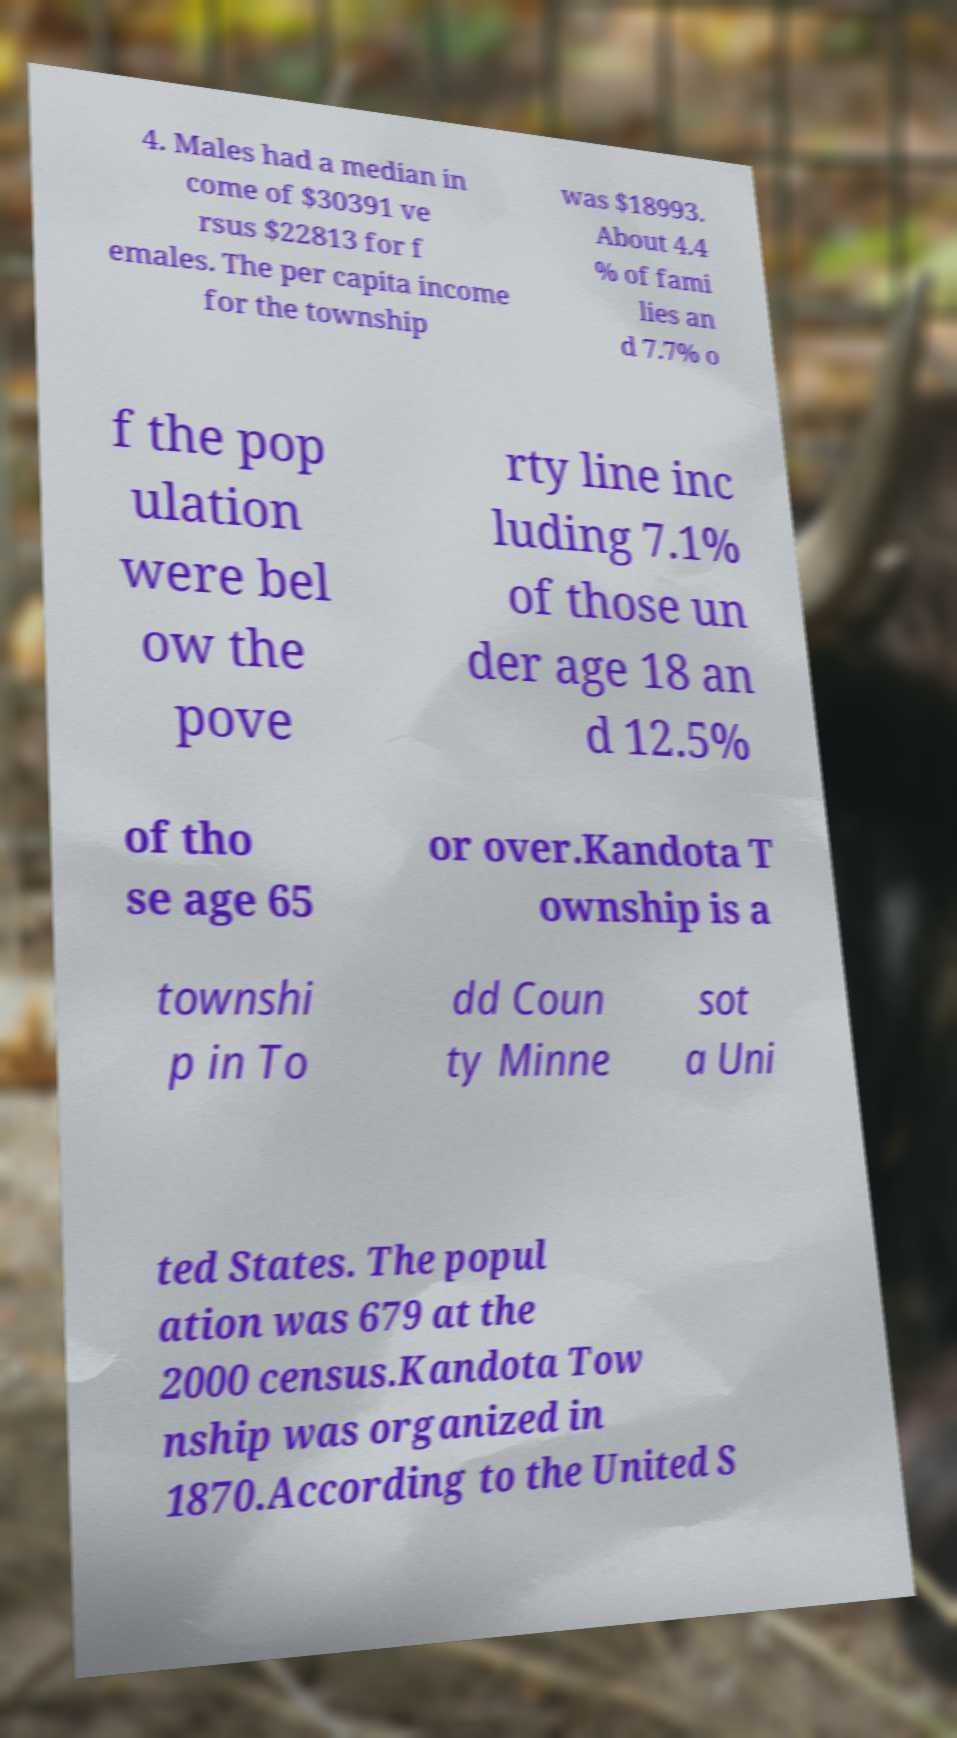Can you accurately transcribe the text from the provided image for me? 4. Males had a median in come of $30391 ve rsus $22813 for f emales. The per capita income for the township was $18993. About 4.4 % of fami lies an d 7.7% o f the pop ulation were bel ow the pove rty line inc luding 7.1% of those un der age 18 an d 12.5% of tho se age 65 or over.Kandota T ownship is a townshi p in To dd Coun ty Minne sot a Uni ted States. The popul ation was 679 at the 2000 census.Kandota Tow nship was organized in 1870.According to the United S 